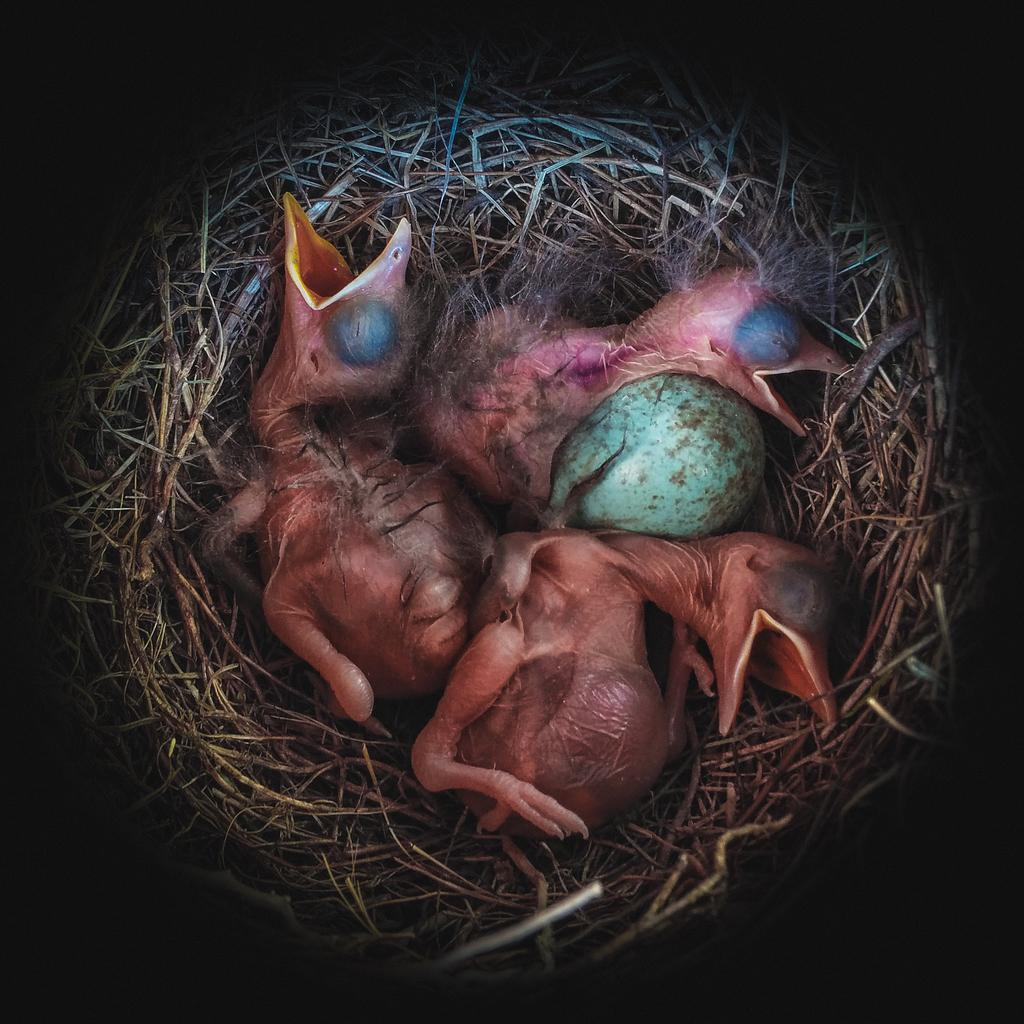What type of animals are in the image? There are baby birds in the image. What is also present in the image along with the baby birds? There is an egg in the image. Where are the baby birds and the egg located? They are in a nest. What part of the image do the baby birds and the nest occupy? The nest is in the foreground of the image. What color is the dirt surrounding the nest in the image? There is no dirt surrounding the nest in the image; the nest is located in a tree or on a branch. 